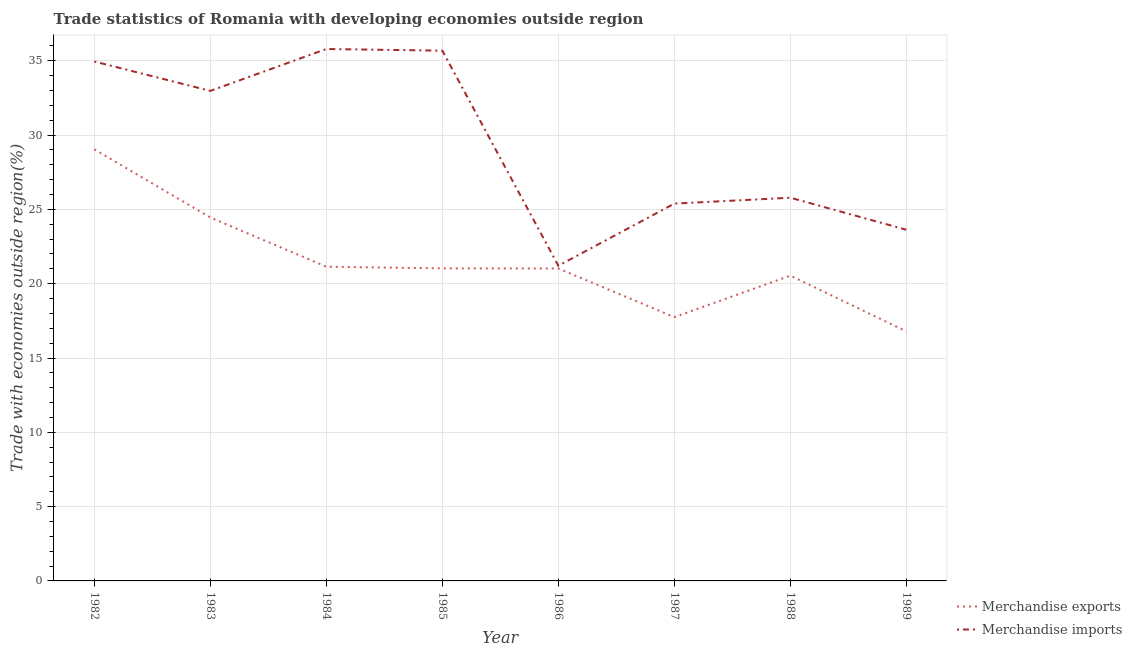Is the number of lines equal to the number of legend labels?
Provide a succinct answer. Yes. What is the merchandise imports in 1988?
Offer a terse response. 25.79. Across all years, what is the maximum merchandise exports?
Your answer should be very brief. 29.04. Across all years, what is the minimum merchandise exports?
Offer a very short reply. 16.79. In which year was the merchandise imports minimum?
Ensure brevity in your answer.  1986. What is the total merchandise imports in the graph?
Your answer should be very brief. 235.42. What is the difference between the merchandise imports in 1983 and that in 1989?
Keep it short and to the point. 9.34. What is the difference between the merchandise imports in 1982 and the merchandise exports in 1987?
Your answer should be very brief. 17.2. What is the average merchandise imports per year?
Your response must be concise. 29.43. In the year 1988, what is the difference between the merchandise imports and merchandise exports?
Provide a short and direct response. 5.24. What is the ratio of the merchandise imports in 1984 to that in 1985?
Provide a short and direct response. 1. What is the difference between the highest and the second highest merchandise imports?
Your response must be concise. 0.11. What is the difference between the highest and the lowest merchandise exports?
Provide a short and direct response. 12.25. Is the merchandise imports strictly greater than the merchandise exports over the years?
Offer a terse response. Yes. Is the merchandise exports strictly less than the merchandise imports over the years?
Your answer should be very brief. Yes. How many lines are there?
Offer a terse response. 2. What is the difference between two consecutive major ticks on the Y-axis?
Ensure brevity in your answer.  5. Are the values on the major ticks of Y-axis written in scientific E-notation?
Your response must be concise. No. Does the graph contain grids?
Ensure brevity in your answer.  Yes. Where does the legend appear in the graph?
Your response must be concise. Bottom right. How are the legend labels stacked?
Provide a succinct answer. Vertical. What is the title of the graph?
Your answer should be compact. Trade statistics of Romania with developing economies outside region. Does "From World Bank" appear as one of the legend labels in the graph?
Your answer should be compact. No. What is the label or title of the Y-axis?
Give a very brief answer. Trade with economies outside region(%). What is the Trade with economies outside region(%) of Merchandise exports in 1982?
Give a very brief answer. 29.04. What is the Trade with economies outside region(%) of Merchandise imports in 1982?
Ensure brevity in your answer.  34.95. What is the Trade with economies outside region(%) in Merchandise exports in 1983?
Ensure brevity in your answer.  24.45. What is the Trade with economies outside region(%) in Merchandise imports in 1983?
Keep it short and to the point. 32.98. What is the Trade with economies outside region(%) of Merchandise exports in 1984?
Your answer should be very brief. 21.14. What is the Trade with economies outside region(%) in Merchandise imports in 1984?
Give a very brief answer. 35.79. What is the Trade with economies outside region(%) in Merchandise exports in 1985?
Your answer should be very brief. 21.03. What is the Trade with economies outside region(%) of Merchandise imports in 1985?
Keep it short and to the point. 35.68. What is the Trade with economies outside region(%) in Merchandise exports in 1986?
Provide a short and direct response. 21.02. What is the Trade with economies outside region(%) in Merchandise imports in 1986?
Keep it short and to the point. 21.21. What is the Trade with economies outside region(%) in Merchandise exports in 1987?
Your answer should be compact. 17.75. What is the Trade with economies outside region(%) in Merchandise imports in 1987?
Make the answer very short. 25.39. What is the Trade with economies outside region(%) in Merchandise exports in 1988?
Your answer should be very brief. 20.55. What is the Trade with economies outside region(%) in Merchandise imports in 1988?
Provide a succinct answer. 25.79. What is the Trade with economies outside region(%) of Merchandise exports in 1989?
Offer a terse response. 16.79. What is the Trade with economies outside region(%) in Merchandise imports in 1989?
Offer a terse response. 23.63. Across all years, what is the maximum Trade with economies outside region(%) of Merchandise exports?
Your response must be concise. 29.04. Across all years, what is the maximum Trade with economies outside region(%) in Merchandise imports?
Your answer should be very brief. 35.79. Across all years, what is the minimum Trade with economies outside region(%) in Merchandise exports?
Offer a terse response. 16.79. Across all years, what is the minimum Trade with economies outside region(%) of Merchandise imports?
Give a very brief answer. 21.21. What is the total Trade with economies outside region(%) in Merchandise exports in the graph?
Keep it short and to the point. 171.79. What is the total Trade with economies outside region(%) of Merchandise imports in the graph?
Keep it short and to the point. 235.42. What is the difference between the Trade with economies outside region(%) of Merchandise exports in 1982 and that in 1983?
Make the answer very short. 4.59. What is the difference between the Trade with economies outside region(%) in Merchandise imports in 1982 and that in 1983?
Your response must be concise. 1.98. What is the difference between the Trade with economies outside region(%) of Merchandise exports in 1982 and that in 1984?
Offer a terse response. 7.9. What is the difference between the Trade with economies outside region(%) in Merchandise imports in 1982 and that in 1984?
Make the answer very short. -0.84. What is the difference between the Trade with economies outside region(%) of Merchandise exports in 1982 and that in 1985?
Your answer should be very brief. 8.01. What is the difference between the Trade with economies outside region(%) in Merchandise imports in 1982 and that in 1985?
Offer a terse response. -0.73. What is the difference between the Trade with economies outside region(%) in Merchandise exports in 1982 and that in 1986?
Offer a very short reply. 8.02. What is the difference between the Trade with economies outside region(%) of Merchandise imports in 1982 and that in 1986?
Provide a succinct answer. 13.74. What is the difference between the Trade with economies outside region(%) of Merchandise exports in 1982 and that in 1987?
Provide a short and direct response. 11.29. What is the difference between the Trade with economies outside region(%) of Merchandise imports in 1982 and that in 1987?
Give a very brief answer. 9.56. What is the difference between the Trade with economies outside region(%) of Merchandise exports in 1982 and that in 1988?
Provide a short and direct response. 8.5. What is the difference between the Trade with economies outside region(%) in Merchandise imports in 1982 and that in 1988?
Your answer should be very brief. 9.17. What is the difference between the Trade with economies outside region(%) of Merchandise exports in 1982 and that in 1989?
Keep it short and to the point. 12.25. What is the difference between the Trade with economies outside region(%) in Merchandise imports in 1982 and that in 1989?
Make the answer very short. 11.32. What is the difference between the Trade with economies outside region(%) in Merchandise exports in 1983 and that in 1984?
Your answer should be very brief. 3.31. What is the difference between the Trade with economies outside region(%) of Merchandise imports in 1983 and that in 1984?
Ensure brevity in your answer.  -2.82. What is the difference between the Trade with economies outside region(%) of Merchandise exports in 1983 and that in 1985?
Ensure brevity in your answer.  3.42. What is the difference between the Trade with economies outside region(%) in Merchandise imports in 1983 and that in 1985?
Your answer should be compact. -2.71. What is the difference between the Trade with economies outside region(%) of Merchandise exports in 1983 and that in 1986?
Provide a succinct answer. 3.43. What is the difference between the Trade with economies outside region(%) in Merchandise imports in 1983 and that in 1986?
Provide a short and direct response. 11.77. What is the difference between the Trade with economies outside region(%) in Merchandise exports in 1983 and that in 1987?
Offer a terse response. 6.7. What is the difference between the Trade with economies outside region(%) in Merchandise imports in 1983 and that in 1987?
Offer a terse response. 7.59. What is the difference between the Trade with economies outside region(%) in Merchandise exports in 1983 and that in 1988?
Offer a very short reply. 3.91. What is the difference between the Trade with economies outside region(%) of Merchandise imports in 1983 and that in 1988?
Keep it short and to the point. 7.19. What is the difference between the Trade with economies outside region(%) of Merchandise exports in 1983 and that in 1989?
Provide a succinct answer. 7.66. What is the difference between the Trade with economies outside region(%) in Merchandise imports in 1983 and that in 1989?
Your response must be concise. 9.34. What is the difference between the Trade with economies outside region(%) in Merchandise exports in 1984 and that in 1985?
Your answer should be very brief. 0.11. What is the difference between the Trade with economies outside region(%) in Merchandise imports in 1984 and that in 1985?
Offer a very short reply. 0.11. What is the difference between the Trade with economies outside region(%) of Merchandise exports in 1984 and that in 1986?
Offer a terse response. 0.12. What is the difference between the Trade with economies outside region(%) in Merchandise imports in 1984 and that in 1986?
Offer a terse response. 14.59. What is the difference between the Trade with economies outside region(%) in Merchandise exports in 1984 and that in 1987?
Your answer should be compact. 3.39. What is the difference between the Trade with economies outside region(%) in Merchandise imports in 1984 and that in 1987?
Provide a short and direct response. 10.4. What is the difference between the Trade with economies outside region(%) in Merchandise exports in 1984 and that in 1988?
Provide a short and direct response. 0.6. What is the difference between the Trade with economies outside region(%) of Merchandise imports in 1984 and that in 1988?
Your response must be concise. 10.01. What is the difference between the Trade with economies outside region(%) of Merchandise exports in 1984 and that in 1989?
Offer a terse response. 4.35. What is the difference between the Trade with economies outside region(%) in Merchandise imports in 1984 and that in 1989?
Provide a short and direct response. 12.16. What is the difference between the Trade with economies outside region(%) of Merchandise exports in 1985 and that in 1986?
Your response must be concise. 0.01. What is the difference between the Trade with economies outside region(%) of Merchandise imports in 1985 and that in 1986?
Give a very brief answer. 14.47. What is the difference between the Trade with economies outside region(%) of Merchandise exports in 1985 and that in 1987?
Ensure brevity in your answer.  3.28. What is the difference between the Trade with economies outside region(%) of Merchandise imports in 1985 and that in 1987?
Your answer should be compact. 10.29. What is the difference between the Trade with economies outside region(%) in Merchandise exports in 1985 and that in 1988?
Your answer should be very brief. 0.49. What is the difference between the Trade with economies outside region(%) in Merchandise imports in 1985 and that in 1988?
Your answer should be very brief. 9.9. What is the difference between the Trade with economies outside region(%) in Merchandise exports in 1985 and that in 1989?
Provide a short and direct response. 4.24. What is the difference between the Trade with economies outside region(%) of Merchandise imports in 1985 and that in 1989?
Provide a succinct answer. 12.05. What is the difference between the Trade with economies outside region(%) in Merchandise exports in 1986 and that in 1987?
Your response must be concise. 3.27. What is the difference between the Trade with economies outside region(%) in Merchandise imports in 1986 and that in 1987?
Provide a short and direct response. -4.18. What is the difference between the Trade with economies outside region(%) in Merchandise exports in 1986 and that in 1988?
Your answer should be very brief. 0.48. What is the difference between the Trade with economies outside region(%) of Merchandise imports in 1986 and that in 1988?
Make the answer very short. -4.58. What is the difference between the Trade with economies outside region(%) of Merchandise exports in 1986 and that in 1989?
Your answer should be compact. 4.23. What is the difference between the Trade with economies outside region(%) of Merchandise imports in 1986 and that in 1989?
Provide a succinct answer. -2.42. What is the difference between the Trade with economies outside region(%) in Merchandise exports in 1987 and that in 1988?
Make the answer very short. -2.79. What is the difference between the Trade with economies outside region(%) of Merchandise imports in 1987 and that in 1988?
Provide a succinct answer. -0.4. What is the difference between the Trade with economies outside region(%) of Merchandise exports in 1987 and that in 1989?
Offer a very short reply. 0.96. What is the difference between the Trade with economies outside region(%) in Merchandise imports in 1987 and that in 1989?
Give a very brief answer. 1.76. What is the difference between the Trade with economies outside region(%) in Merchandise exports in 1988 and that in 1989?
Make the answer very short. 3.75. What is the difference between the Trade with economies outside region(%) in Merchandise imports in 1988 and that in 1989?
Give a very brief answer. 2.15. What is the difference between the Trade with economies outside region(%) in Merchandise exports in 1982 and the Trade with economies outside region(%) in Merchandise imports in 1983?
Make the answer very short. -3.93. What is the difference between the Trade with economies outside region(%) in Merchandise exports in 1982 and the Trade with economies outside region(%) in Merchandise imports in 1984?
Make the answer very short. -6.75. What is the difference between the Trade with economies outside region(%) in Merchandise exports in 1982 and the Trade with economies outside region(%) in Merchandise imports in 1985?
Provide a short and direct response. -6.64. What is the difference between the Trade with economies outside region(%) of Merchandise exports in 1982 and the Trade with economies outside region(%) of Merchandise imports in 1986?
Offer a terse response. 7.83. What is the difference between the Trade with economies outside region(%) in Merchandise exports in 1982 and the Trade with economies outside region(%) in Merchandise imports in 1987?
Make the answer very short. 3.65. What is the difference between the Trade with economies outside region(%) in Merchandise exports in 1982 and the Trade with economies outside region(%) in Merchandise imports in 1988?
Your answer should be compact. 3.26. What is the difference between the Trade with economies outside region(%) in Merchandise exports in 1982 and the Trade with economies outside region(%) in Merchandise imports in 1989?
Offer a very short reply. 5.41. What is the difference between the Trade with economies outside region(%) of Merchandise exports in 1983 and the Trade with economies outside region(%) of Merchandise imports in 1984?
Offer a very short reply. -11.34. What is the difference between the Trade with economies outside region(%) of Merchandise exports in 1983 and the Trade with economies outside region(%) of Merchandise imports in 1985?
Give a very brief answer. -11.23. What is the difference between the Trade with economies outside region(%) of Merchandise exports in 1983 and the Trade with economies outside region(%) of Merchandise imports in 1986?
Offer a terse response. 3.25. What is the difference between the Trade with economies outside region(%) in Merchandise exports in 1983 and the Trade with economies outside region(%) in Merchandise imports in 1987?
Keep it short and to the point. -0.94. What is the difference between the Trade with economies outside region(%) of Merchandise exports in 1983 and the Trade with economies outside region(%) of Merchandise imports in 1988?
Ensure brevity in your answer.  -1.33. What is the difference between the Trade with economies outside region(%) of Merchandise exports in 1983 and the Trade with economies outside region(%) of Merchandise imports in 1989?
Offer a terse response. 0.82. What is the difference between the Trade with economies outside region(%) of Merchandise exports in 1984 and the Trade with economies outside region(%) of Merchandise imports in 1985?
Your answer should be very brief. -14.54. What is the difference between the Trade with economies outside region(%) of Merchandise exports in 1984 and the Trade with economies outside region(%) of Merchandise imports in 1986?
Provide a succinct answer. -0.06. What is the difference between the Trade with economies outside region(%) of Merchandise exports in 1984 and the Trade with economies outside region(%) of Merchandise imports in 1987?
Keep it short and to the point. -4.25. What is the difference between the Trade with economies outside region(%) in Merchandise exports in 1984 and the Trade with economies outside region(%) in Merchandise imports in 1988?
Make the answer very short. -4.64. What is the difference between the Trade with economies outside region(%) in Merchandise exports in 1984 and the Trade with economies outside region(%) in Merchandise imports in 1989?
Provide a succinct answer. -2.49. What is the difference between the Trade with economies outside region(%) of Merchandise exports in 1985 and the Trade with economies outside region(%) of Merchandise imports in 1986?
Provide a short and direct response. -0.18. What is the difference between the Trade with economies outside region(%) of Merchandise exports in 1985 and the Trade with economies outside region(%) of Merchandise imports in 1987?
Your answer should be compact. -4.36. What is the difference between the Trade with economies outside region(%) in Merchandise exports in 1985 and the Trade with economies outside region(%) in Merchandise imports in 1988?
Give a very brief answer. -4.75. What is the difference between the Trade with economies outside region(%) in Merchandise exports in 1985 and the Trade with economies outside region(%) in Merchandise imports in 1989?
Provide a short and direct response. -2.6. What is the difference between the Trade with economies outside region(%) of Merchandise exports in 1986 and the Trade with economies outside region(%) of Merchandise imports in 1987?
Offer a very short reply. -4.37. What is the difference between the Trade with economies outside region(%) in Merchandise exports in 1986 and the Trade with economies outside region(%) in Merchandise imports in 1988?
Provide a short and direct response. -4.76. What is the difference between the Trade with economies outside region(%) in Merchandise exports in 1986 and the Trade with economies outside region(%) in Merchandise imports in 1989?
Your answer should be very brief. -2.61. What is the difference between the Trade with economies outside region(%) in Merchandise exports in 1987 and the Trade with economies outside region(%) in Merchandise imports in 1988?
Give a very brief answer. -8.03. What is the difference between the Trade with economies outside region(%) of Merchandise exports in 1987 and the Trade with economies outside region(%) of Merchandise imports in 1989?
Provide a short and direct response. -5.88. What is the difference between the Trade with economies outside region(%) of Merchandise exports in 1988 and the Trade with economies outside region(%) of Merchandise imports in 1989?
Keep it short and to the point. -3.09. What is the average Trade with economies outside region(%) of Merchandise exports per year?
Your answer should be very brief. 21.47. What is the average Trade with economies outside region(%) of Merchandise imports per year?
Your answer should be very brief. 29.43. In the year 1982, what is the difference between the Trade with economies outside region(%) of Merchandise exports and Trade with economies outside region(%) of Merchandise imports?
Your answer should be compact. -5.91. In the year 1983, what is the difference between the Trade with economies outside region(%) of Merchandise exports and Trade with economies outside region(%) of Merchandise imports?
Offer a terse response. -8.52. In the year 1984, what is the difference between the Trade with economies outside region(%) of Merchandise exports and Trade with economies outside region(%) of Merchandise imports?
Provide a short and direct response. -14.65. In the year 1985, what is the difference between the Trade with economies outside region(%) of Merchandise exports and Trade with economies outside region(%) of Merchandise imports?
Offer a terse response. -14.65. In the year 1986, what is the difference between the Trade with economies outside region(%) in Merchandise exports and Trade with economies outside region(%) in Merchandise imports?
Your answer should be very brief. -0.18. In the year 1987, what is the difference between the Trade with economies outside region(%) in Merchandise exports and Trade with economies outside region(%) in Merchandise imports?
Keep it short and to the point. -7.64. In the year 1988, what is the difference between the Trade with economies outside region(%) of Merchandise exports and Trade with economies outside region(%) of Merchandise imports?
Provide a succinct answer. -5.24. In the year 1989, what is the difference between the Trade with economies outside region(%) of Merchandise exports and Trade with economies outside region(%) of Merchandise imports?
Keep it short and to the point. -6.84. What is the ratio of the Trade with economies outside region(%) of Merchandise exports in 1982 to that in 1983?
Ensure brevity in your answer.  1.19. What is the ratio of the Trade with economies outside region(%) of Merchandise imports in 1982 to that in 1983?
Keep it short and to the point. 1.06. What is the ratio of the Trade with economies outside region(%) of Merchandise exports in 1982 to that in 1984?
Keep it short and to the point. 1.37. What is the ratio of the Trade with economies outside region(%) in Merchandise imports in 1982 to that in 1984?
Give a very brief answer. 0.98. What is the ratio of the Trade with economies outside region(%) in Merchandise exports in 1982 to that in 1985?
Provide a succinct answer. 1.38. What is the ratio of the Trade with economies outside region(%) of Merchandise imports in 1982 to that in 1985?
Provide a short and direct response. 0.98. What is the ratio of the Trade with economies outside region(%) of Merchandise exports in 1982 to that in 1986?
Provide a short and direct response. 1.38. What is the ratio of the Trade with economies outside region(%) of Merchandise imports in 1982 to that in 1986?
Offer a terse response. 1.65. What is the ratio of the Trade with economies outside region(%) in Merchandise exports in 1982 to that in 1987?
Make the answer very short. 1.64. What is the ratio of the Trade with economies outside region(%) of Merchandise imports in 1982 to that in 1987?
Offer a terse response. 1.38. What is the ratio of the Trade with economies outside region(%) in Merchandise exports in 1982 to that in 1988?
Offer a terse response. 1.41. What is the ratio of the Trade with economies outside region(%) of Merchandise imports in 1982 to that in 1988?
Provide a short and direct response. 1.36. What is the ratio of the Trade with economies outside region(%) in Merchandise exports in 1982 to that in 1989?
Your answer should be compact. 1.73. What is the ratio of the Trade with economies outside region(%) of Merchandise imports in 1982 to that in 1989?
Provide a succinct answer. 1.48. What is the ratio of the Trade with economies outside region(%) of Merchandise exports in 1983 to that in 1984?
Your answer should be very brief. 1.16. What is the ratio of the Trade with economies outside region(%) of Merchandise imports in 1983 to that in 1984?
Give a very brief answer. 0.92. What is the ratio of the Trade with economies outside region(%) in Merchandise exports in 1983 to that in 1985?
Provide a short and direct response. 1.16. What is the ratio of the Trade with economies outside region(%) in Merchandise imports in 1983 to that in 1985?
Offer a very short reply. 0.92. What is the ratio of the Trade with economies outside region(%) of Merchandise exports in 1983 to that in 1986?
Offer a terse response. 1.16. What is the ratio of the Trade with economies outside region(%) of Merchandise imports in 1983 to that in 1986?
Your answer should be very brief. 1.55. What is the ratio of the Trade with economies outside region(%) of Merchandise exports in 1983 to that in 1987?
Make the answer very short. 1.38. What is the ratio of the Trade with economies outside region(%) in Merchandise imports in 1983 to that in 1987?
Your answer should be compact. 1.3. What is the ratio of the Trade with economies outside region(%) of Merchandise exports in 1983 to that in 1988?
Your response must be concise. 1.19. What is the ratio of the Trade with economies outside region(%) in Merchandise imports in 1983 to that in 1988?
Ensure brevity in your answer.  1.28. What is the ratio of the Trade with economies outside region(%) of Merchandise exports in 1983 to that in 1989?
Provide a short and direct response. 1.46. What is the ratio of the Trade with economies outside region(%) of Merchandise imports in 1983 to that in 1989?
Offer a very short reply. 1.4. What is the ratio of the Trade with economies outside region(%) in Merchandise exports in 1984 to that in 1985?
Provide a short and direct response. 1.01. What is the ratio of the Trade with economies outside region(%) of Merchandise exports in 1984 to that in 1986?
Offer a terse response. 1.01. What is the ratio of the Trade with economies outside region(%) in Merchandise imports in 1984 to that in 1986?
Give a very brief answer. 1.69. What is the ratio of the Trade with economies outside region(%) of Merchandise exports in 1984 to that in 1987?
Keep it short and to the point. 1.19. What is the ratio of the Trade with economies outside region(%) in Merchandise imports in 1984 to that in 1987?
Keep it short and to the point. 1.41. What is the ratio of the Trade with economies outside region(%) of Merchandise exports in 1984 to that in 1988?
Offer a terse response. 1.03. What is the ratio of the Trade with economies outside region(%) of Merchandise imports in 1984 to that in 1988?
Offer a very short reply. 1.39. What is the ratio of the Trade with economies outside region(%) in Merchandise exports in 1984 to that in 1989?
Ensure brevity in your answer.  1.26. What is the ratio of the Trade with economies outside region(%) of Merchandise imports in 1984 to that in 1989?
Your answer should be compact. 1.51. What is the ratio of the Trade with economies outside region(%) of Merchandise imports in 1985 to that in 1986?
Your answer should be compact. 1.68. What is the ratio of the Trade with economies outside region(%) of Merchandise exports in 1985 to that in 1987?
Provide a succinct answer. 1.18. What is the ratio of the Trade with economies outside region(%) in Merchandise imports in 1985 to that in 1987?
Make the answer very short. 1.41. What is the ratio of the Trade with economies outside region(%) of Merchandise exports in 1985 to that in 1988?
Ensure brevity in your answer.  1.02. What is the ratio of the Trade with economies outside region(%) of Merchandise imports in 1985 to that in 1988?
Your response must be concise. 1.38. What is the ratio of the Trade with economies outside region(%) of Merchandise exports in 1985 to that in 1989?
Provide a short and direct response. 1.25. What is the ratio of the Trade with economies outside region(%) in Merchandise imports in 1985 to that in 1989?
Your response must be concise. 1.51. What is the ratio of the Trade with economies outside region(%) in Merchandise exports in 1986 to that in 1987?
Give a very brief answer. 1.18. What is the ratio of the Trade with economies outside region(%) of Merchandise imports in 1986 to that in 1987?
Ensure brevity in your answer.  0.84. What is the ratio of the Trade with economies outside region(%) in Merchandise exports in 1986 to that in 1988?
Make the answer very short. 1.02. What is the ratio of the Trade with economies outside region(%) of Merchandise imports in 1986 to that in 1988?
Provide a succinct answer. 0.82. What is the ratio of the Trade with economies outside region(%) in Merchandise exports in 1986 to that in 1989?
Ensure brevity in your answer.  1.25. What is the ratio of the Trade with economies outside region(%) of Merchandise imports in 1986 to that in 1989?
Your answer should be compact. 0.9. What is the ratio of the Trade with economies outside region(%) of Merchandise exports in 1987 to that in 1988?
Your answer should be very brief. 0.86. What is the ratio of the Trade with economies outside region(%) of Merchandise imports in 1987 to that in 1988?
Provide a succinct answer. 0.98. What is the ratio of the Trade with economies outside region(%) in Merchandise exports in 1987 to that in 1989?
Your answer should be compact. 1.06. What is the ratio of the Trade with economies outside region(%) of Merchandise imports in 1987 to that in 1989?
Your answer should be very brief. 1.07. What is the ratio of the Trade with economies outside region(%) of Merchandise exports in 1988 to that in 1989?
Give a very brief answer. 1.22. What is the ratio of the Trade with economies outside region(%) in Merchandise imports in 1988 to that in 1989?
Offer a terse response. 1.09. What is the difference between the highest and the second highest Trade with economies outside region(%) in Merchandise exports?
Offer a terse response. 4.59. What is the difference between the highest and the second highest Trade with economies outside region(%) in Merchandise imports?
Keep it short and to the point. 0.11. What is the difference between the highest and the lowest Trade with economies outside region(%) of Merchandise exports?
Provide a succinct answer. 12.25. What is the difference between the highest and the lowest Trade with economies outside region(%) of Merchandise imports?
Offer a very short reply. 14.59. 